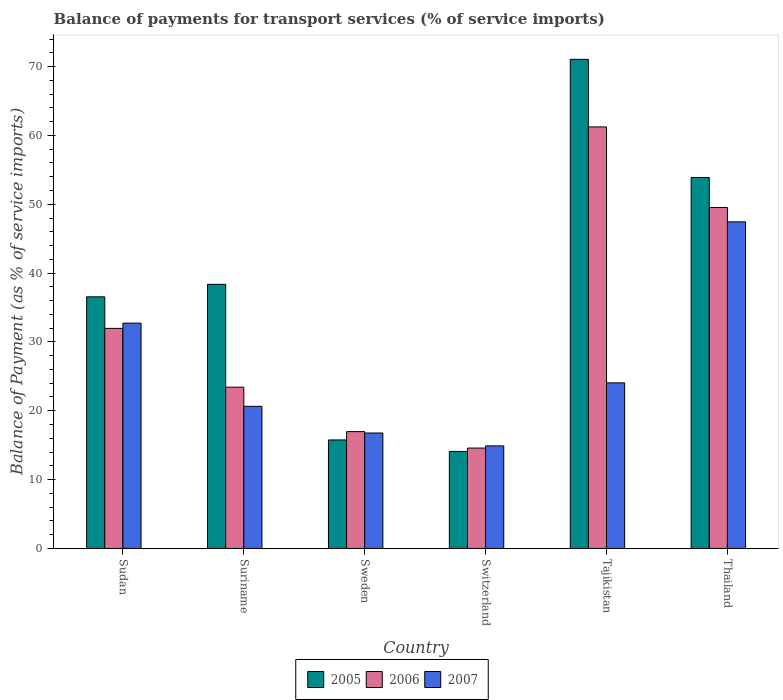What is the label of the 5th group of bars from the left?
Offer a terse response. Tajikistan. In how many cases, is the number of bars for a given country not equal to the number of legend labels?
Your response must be concise. 0. What is the balance of payments for transport services in 2006 in Switzerland?
Offer a very short reply. 14.58. Across all countries, what is the maximum balance of payments for transport services in 2006?
Offer a terse response. 61.23. Across all countries, what is the minimum balance of payments for transport services in 2006?
Keep it short and to the point. 14.58. In which country was the balance of payments for transport services in 2007 maximum?
Keep it short and to the point. Thailand. In which country was the balance of payments for transport services in 2005 minimum?
Provide a short and direct response. Switzerland. What is the total balance of payments for transport services in 2005 in the graph?
Offer a terse response. 229.7. What is the difference between the balance of payments for transport services in 2005 in Sudan and that in Tajikistan?
Offer a terse response. -34.5. What is the difference between the balance of payments for transport services in 2007 in Thailand and the balance of payments for transport services in 2005 in Suriname?
Ensure brevity in your answer.  9.08. What is the average balance of payments for transport services in 2005 per country?
Give a very brief answer. 38.28. What is the difference between the balance of payments for transport services of/in 2006 and balance of payments for transport services of/in 2005 in Thailand?
Your answer should be compact. -4.36. What is the ratio of the balance of payments for transport services in 2006 in Sudan to that in Suriname?
Your response must be concise. 1.36. Is the balance of payments for transport services in 2007 in Suriname less than that in Switzerland?
Keep it short and to the point. No. Is the difference between the balance of payments for transport services in 2006 in Sudan and Suriname greater than the difference between the balance of payments for transport services in 2005 in Sudan and Suriname?
Keep it short and to the point. Yes. What is the difference between the highest and the second highest balance of payments for transport services in 2007?
Make the answer very short. 8.68. What is the difference between the highest and the lowest balance of payments for transport services in 2007?
Offer a terse response. 32.54. In how many countries, is the balance of payments for transport services in 2007 greater than the average balance of payments for transport services in 2007 taken over all countries?
Make the answer very short. 2. What does the 1st bar from the right in Tajikistan represents?
Offer a very short reply. 2007. Is it the case that in every country, the sum of the balance of payments for transport services in 2005 and balance of payments for transport services in 2007 is greater than the balance of payments for transport services in 2006?
Your answer should be very brief. Yes. Are all the bars in the graph horizontal?
Give a very brief answer. No. How many countries are there in the graph?
Keep it short and to the point. 6. What is the difference between two consecutive major ticks on the Y-axis?
Provide a succinct answer. 10. Are the values on the major ticks of Y-axis written in scientific E-notation?
Make the answer very short. No. Does the graph contain any zero values?
Your answer should be very brief. No. Does the graph contain grids?
Offer a very short reply. No. Where does the legend appear in the graph?
Provide a succinct answer. Bottom center. How many legend labels are there?
Make the answer very short. 3. How are the legend labels stacked?
Provide a succinct answer. Horizontal. What is the title of the graph?
Ensure brevity in your answer.  Balance of payments for transport services (% of service imports). Does "2015" appear as one of the legend labels in the graph?
Give a very brief answer. No. What is the label or title of the X-axis?
Your answer should be very brief. Country. What is the label or title of the Y-axis?
Your answer should be compact. Balance of Payment (as % of service imports). What is the Balance of Payment (as % of service imports) of 2005 in Sudan?
Make the answer very short. 36.55. What is the Balance of Payment (as % of service imports) of 2006 in Sudan?
Make the answer very short. 31.96. What is the Balance of Payment (as % of service imports) in 2007 in Sudan?
Give a very brief answer. 32.73. What is the Balance of Payment (as % of service imports) of 2005 in Suriname?
Provide a short and direct response. 38.37. What is the Balance of Payment (as % of service imports) in 2006 in Suriname?
Offer a terse response. 23.42. What is the Balance of Payment (as % of service imports) in 2007 in Suriname?
Give a very brief answer. 20.64. What is the Balance of Payment (as % of service imports) of 2005 in Sweden?
Your answer should be compact. 15.76. What is the Balance of Payment (as % of service imports) of 2006 in Sweden?
Give a very brief answer. 16.97. What is the Balance of Payment (as % of service imports) in 2007 in Sweden?
Keep it short and to the point. 16.77. What is the Balance of Payment (as % of service imports) in 2005 in Switzerland?
Keep it short and to the point. 14.09. What is the Balance of Payment (as % of service imports) in 2006 in Switzerland?
Your response must be concise. 14.58. What is the Balance of Payment (as % of service imports) in 2007 in Switzerland?
Provide a short and direct response. 14.9. What is the Balance of Payment (as % of service imports) of 2005 in Tajikistan?
Keep it short and to the point. 71.05. What is the Balance of Payment (as % of service imports) of 2006 in Tajikistan?
Make the answer very short. 61.23. What is the Balance of Payment (as % of service imports) in 2007 in Tajikistan?
Offer a very short reply. 24.05. What is the Balance of Payment (as % of service imports) of 2005 in Thailand?
Make the answer very short. 53.88. What is the Balance of Payment (as % of service imports) in 2006 in Thailand?
Make the answer very short. 49.53. What is the Balance of Payment (as % of service imports) in 2007 in Thailand?
Provide a short and direct response. 47.44. Across all countries, what is the maximum Balance of Payment (as % of service imports) of 2005?
Ensure brevity in your answer.  71.05. Across all countries, what is the maximum Balance of Payment (as % of service imports) in 2006?
Give a very brief answer. 61.23. Across all countries, what is the maximum Balance of Payment (as % of service imports) of 2007?
Provide a short and direct response. 47.44. Across all countries, what is the minimum Balance of Payment (as % of service imports) in 2005?
Offer a very short reply. 14.09. Across all countries, what is the minimum Balance of Payment (as % of service imports) of 2006?
Keep it short and to the point. 14.58. Across all countries, what is the minimum Balance of Payment (as % of service imports) in 2007?
Keep it short and to the point. 14.9. What is the total Balance of Payment (as % of service imports) of 2005 in the graph?
Provide a short and direct response. 229.7. What is the total Balance of Payment (as % of service imports) in 2006 in the graph?
Make the answer very short. 197.7. What is the total Balance of Payment (as % of service imports) of 2007 in the graph?
Make the answer very short. 156.53. What is the difference between the Balance of Payment (as % of service imports) of 2005 in Sudan and that in Suriname?
Give a very brief answer. -1.82. What is the difference between the Balance of Payment (as % of service imports) in 2006 in Sudan and that in Suriname?
Offer a terse response. 8.54. What is the difference between the Balance of Payment (as % of service imports) of 2007 in Sudan and that in Suriname?
Make the answer very short. 12.08. What is the difference between the Balance of Payment (as % of service imports) of 2005 in Sudan and that in Sweden?
Make the answer very short. 20.79. What is the difference between the Balance of Payment (as % of service imports) in 2006 in Sudan and that in Sweden?
Make the answer very short. 14.99. What is the difference between the Balance of Payment (as % of service imports) of 2007 in Sudan and that in Sweden?
Offer a terse response. 15.96. What is the difference between the Balance of Payment (as % of service imports) in 2005 in Sudan and that in Switzerland?
Offer a terse response. 22.46. What is the difference between the Balance of Payment (as % of service imports) in 2006 in Sudan and that in Switzerland?
Your answer should be compact. 17.38. What is the difference between the Balance of Payment (as % of service imports) of 2007 in Sudan and that in Switzerland?
Your answer should be very brief. 17.83. What is the difference between the Balance of Payment (as % of service imports) in 2005 in Sudan and that in Tajikistan?
Provide a short and direct response. -34.5. What is the difference between the Balance of Payment (as % of service imports) in 2006 in Sudan and that in Tajikistan?
Make the answer very short. -29.27. What is the difference between the Balance of Payment (as % of service imports) of 2007 in Sudan and that in Tajikistan?
Offer a terse response. 8.68. What is the difference between the Balance of Payment (as % of service imports) in 2005 in Sudan and that in Thailand?
Give a very brief answer. -17.33. What is the difference between the Balance of Payment (as % of service imports) in 2006 in Sudan and that in Thailand?
Give a very brief answer. -17.56. What is the difference between the Balance of Payment (as % of service imports) of 2007 in Sudan and that in Thailand?
Your answer should be compact. -14.71. What is the difference between the Balance of Payment (as % of service imports) of 2005 in Suriname and that in Sweden?
Give a very brief answer. 22.6. What is the difference between the Balance of Payment (as % of service imports) in 2006 in Suriname and that in Sweden?
Provide a short and direct response. 6.45. What is the difference between the Balance of Payment (as % of service imports) of 2007 in Suriname and that in Sweden?
Give a very brief answer. 3.88. What is the difference between the Balance of Payment (as % of service imports) of 2005 in Suriname and that in Switzerland?
Provide a short and direct response. 24.28. What is the difference between the Balance of Payment (as % of service imports) of 2006 in Suriname and that in Switzerland?
Give a very brief answer. 8.84. What is the difference between the Balance of Payment (as % of service imports) of 2007 in Suriname and that in Switzerland?
Your answer should be compact. 5.75. What is the difference between the Balance of Payment (as % of service imports) of 2005 in Suriname and that in Tajikistan?
Give a very brief answer. -32.68. What is the difference between the Balance of Payment (as % of service imports) in 2006 in Suriname and that in Tajikistan?
Your response must be concise. -37.81. What is the difference between the Balance of Payment (as % of service imports) of 2007 in Suriname and that in Tajikistan?
Provide a succinct answer. -3.41. What is the difference between the Balance of Payment (as % of service imports) in 2005 in Suriname and that in Thailand?
Give a very brief answer. -15.52. What is the difference between the Balance of Payment (as % of service imports) of 2006 in Suriname and that in Thailand?
Your answer should be very brief. -26.1. What is the difference between the Balance of Payment (as % of service imports) of 2007 in Suriname and that in Thailand?
Your answer should be compact. -26.8. What is the difference between the Balance of Payment (as % of service imports) in 2005 in Sweden and that in Switzerland?
Provide a succinct answer. 1.67. What is the difference between the Balance of Payment (as % of service imports) in 2006 in Sweden and that in Switzerland?
Offer a terse response. 2.39. What is the difference between the Balance of Payment (as % of service imports) of 2007 in Sweden and that in Switzerland?
Provide a succinct answer. 1.87. What is the difference between the Balance of Payment (as % of service imports) of 2005 in Sweden and that in Tajikistan?
Your answer should be compact. -55.29. What is the difference between the Balance of Payment (as % of service imports) of 2006 in Sweden and that in Tajikistan?
Offer a very short reply. -44.26. What is the difference between the Balance of Payment (as % of service imports) in 2007 in Sweden and that in Tajikistan?
Your response must be concise. -7.29. What is the difference between the Balance of Payment (as % of service imports) of 2005 in Sweden and that in Thailand?
Make the answer very short. -38.12. What is the difference between the Balance of Payment (as % of service imports) in 2006 in Sweden and that in Thailand?
Provide a short and direct response. -32.56. What is the difference between the Balance of Payment (as % of service imports) in 2007 in Sweden and that in Thailand?
Provide a succinct answer. -30.67. What is the difference between the Balance of Payment (as % of service imports) in 2005 in Switzerland and that in Tajikistan?
Keep it short and to the point. -56.96. What is the difference between the Balance of Payment (as % of service imports) of 2006 in Switzerland and that in Tajikistan?
Make the answer very short. -46.65. What is the difference between the Balance of Payment (as % of service imports) in 2007 in Switzerland and that in Tajikistan?
Your response must be concise. -9.16. What is the difference between the Balance of Payment (as % of service imports) of 2005 in Switzerland and that in Thailand?
Make the answer very short. -39.79. What is the difference between the Balance of Payment (as % of service imports) in 2006 in Switzerland and that in Thailand?
Provide a succinct answer. -34.95. What is the difference between the Balance of Payment (as % of service imports) of 2007 in Switzerland and that in Thailand?
Offer a very short reply. -32.54. What is the difference between the Balance of Payment (as % of service imports) of 2005 in Tajikistan and that in Thailand?
Keep it short and to the point. 17.16. What is the difference between the Balance of Payment (as % of service imports) of 2006 in Tajikistan and that in Thailand?
Offer a very short reply. 11.7. What is the difference between the Balance of Payment (as % of service imports) of 2007 in Tajikistan and that in Thailand?
Offer a terse response. -23.39. What is the difference between the Balance of Payment (as % of service imports) in 2005 in Sudan and the Balance of Payment (as % of service imports) in 2006 in Suriname?
Offer a terse response. 13.13. What is the difference between the Balance of Payment (as % of service imports) of 2005 in Sudan and the Balance of Payment (as % of service imports) of 2007 in Suriname?
Your answer should be very brief. 15.91. What is the difference between the Balance of Payment (as % of service imports) of 2006 in Sudan and the Balance of Payment (as % of service imports) of 2007 in Suriname?
Your answer should be compact. 11.32. What is the difference between the Balance of Payment (as % of service imports) of 2005 in Sudan and the Balance of Payment (as % of service imports) of 2006 in Sweden?
Offer a very short reply. 19.58. What is the difference between the Balance of Payment (as % of service imports) of 2005 in Sudan and the Balance of Payment (as % of service imports) of 2007 in Sweden?
Give a very brief answer. 19.78. What is the difference between the Balance of Payment (as % of service imports) in 2006 in Sudan and the Balance of Payment (as % of service imports) in 2007 in Sweden?
Provide a succinct answer. 15.2. What is the difference between the Balance of Payment (as % of service imports) in 2005 in Sudan and the Balance of Payment (as % of service imports) in 2006 in Switzerland?
Offer a very short reply. 21.97. What is the difference between the Balance of Payment (as % of service imports) in 2005 in Sudan and the Balance of Payment (as % of service imports) in 2007 in Switzerland?
Provide a succinct answer. 21.65. What is the difference between the Balance of Payment (as % of service imports) of 2006 in Sudan and the Balance of Payment (as % of service imports) of 2007 in Switzerland?
Make the answer very short. 17.07. What is the difference between the Balance of Payment (as % of service imports) of 2005 in Sudan and the Balance of Payment (as % of service imports) of 2006 in Tajikistan?
Your answer should be compact. -24.68. What is the difference between the Balance of Payment (as % of service imports) of 2005 in Sudan and the Balance of Payment (as % of service imports) of 2007 in Tajikistan?
Your answer should be compact. 12.5. What is the difference between the Balance of Payment (as % of service imports) of 2006 in Sudan and the Balance of Payment (as % of service imports) of 2007 in Tajikistan?
Keep it short and to the point. 7.91. What is the difference between the Balance of Payment (as % of service imports) of 2005 in Sudan and the Balance of Payment (as % of service imports) of 2006 in Thailand?
Your response must be concise. -12.98. What is the difference between the Balance of Payment (as % of service imports) of 2005 in Sudan and the Balance of Payment (as % of service imports) of 2007 in Thailand?
Your answer should be compact. -10.89. What is the difference between the Balance of Payment (as % of service imports) of 2006 in Sudan and the Balance of Payment (as % of service imports) of 2007 in Thailand?
Provide a short and direct response. -15.48. What is the difference between the Balance of Payment (as % of service imports) of 2005 in Suriname and the Balance of Payment (as % of service imports) of 2006 in Sweden?
Give a very brief answer. 21.4. What is the difference between the Balance of Payment (as % of service imports) of 2005 in Suriname and the Balance of Payment (as % of service imports) of 2007 in Sweden?
Give a very brief answer. 21.6. What is the difference between the Balance of Payment (as % of service imports) in 2006 in Suriname and the Balance of Payment (as % of service imports) in 2007 in Sweden?
Ensure brevity in your answer.  6.66. What is the difference between the Balance of Payment (as % of service imports) of 2005 in Suriname and the Balance of Payment (as % of service imports) of 2006 in Switzerland?
Keep it short and to the point. 23.78. What is the difference between the Balance of Payment (as % of service imports) in 2005 in Suriname and the Balance of Payment (as % of service imports) in 2007 in Switzerland?
Ensure brevity in your answer.  23.47. What is the difference between the Balance of Payment (as % of service imports) in 2006 in Suriname and the Balance of Payment (as % of service imports) in 2007 in Switzerland?
Keep it short and to the point. 8.53. What is the difference between the Balance of Payment (as % of service imports) in 2005 in Suriname and the Balance of Payment (as % of service imports) in 2006 in Tajikistan?
Ensure brevity in your answer.  -22.87. What is the difference between the Balance of Payment (as % of service imports) in 2005 in Suriname and the Balance of Payment (as % of service imports) in 2007 in Tajikistan?
Make the answer very short. 14.31. What is the difference between the Balance of Payment (as % of service imports) of 2006 in Suriname and the Balance of Payment (as % of service imports) of 2007 in Tajikistan?
Make the answer very short. -0.63. What is the difference between the Balance of Payment (as % of service imports) of 2005 in Suriname and the Balance of Payment (as % of service imports) of 2006 in Thailand?
Provide a succinct answer. -11.16. What is the difference between the Balance of Payment (as % of service imports) of 2005 in Suriname and the Balance of Payment (as % of service imports) of 2007 in Thailand?
Offer a very short reply. -9.08. What is the difference between the Balance of Payment (as % of service imports) of 2006 in Suriname and the Balance of Payment (as % of service imports) of 2007 in Thailand?
Provide a short and direct response. -24.02. What is the difference between the Balance of Payment (as % of service imports) in 2005 in Sweden and the Balance of Payment (as % of service imports) in 2006 in Switzerland?
Make the answer very short. 1.18. What is the difference between the Balance of Payment (as % of service imports) in 2005 in Sweden and the Balance of Payment (as % of service imports) in 2007 in Switzerland?
Offer a terse response. 0.87. What is the difference between the Balance of Payment (as % of service imports) of 2006 in Sweden and the Balance of Payment (as % of service imports) of 2007 in Switzerland?
Offer a very short reply. 2.07. What is the difference between the Balance of Payment (as % of service imports) in 2005 in Sweden and the Balance of Payment (as % of service imports) in 2006 in Tajikistan?
Keep it short and to the point. -45.47. What is the difference between the Balance of Payment (as % of service imports) of 2005 in Sweden and the Balance of Payment (as % of service imports) of 2007 in Tajikistan?
Your answer should be very brief. -8.29. What is the difference between the Balance of Payment (as % of service imports) of 2006 in Sweden and the Balance of Payment (as % of service imports) of 2007 in Tajikistan?
Your answer should be very brief. -7.08. What is the difference between the Balance of Payment (as % of service imports) of 2005 in Sweden and the Balance of Payment (as % of service imports) of 2006 in Thailand?
Offer a terse response. -33.77. What is the difference between the Balance of Payment (as % of service imports) in 2005 in Sweden and the Balance of Payment (as % of service imports) in 2007 in Thailand?
Provide a succinct answer. -31.68. What is the difference between the Balance of Payment (as % of service imports) of 2006 in Sweden and the Balance of Payment (as % of service imports) of 2007 in Thailand?
Your answer should be compact. -30.47. What is the difference between the Balance of Payment (as % of service imports) in 2005 in Switzerland and the Balance of Payment (as % of service imports) in 2006 in Tajikistan?
Provide a short and direct response. -47.14. What is the difference between the Balance of Payment (as % of service imports) in 2005 in Switzerland and the Balance of Payment (as % of service imports) in 2007 in Tajikistan?
Offer a terse response. -9.96. What is the difference between the Balance of Payment (as % of service imports) in 2006 in Switzerland and the Balance of Payment (as % of service imports) in 2007 in Tajikistan?
Your answer should be very brief. -9.47. What is the difference between the Balance of Payment (as % of service imports) of 2005 in Switzerland and the Balance of Payment (as % of service imports) of 2006 in Thailand?
Provide a succinct answer. -35.44. What is the difference between the Balance of Payment (as % of service imports) of 2005 in Switzerland and the Balance of Payment (as % of service imports) of 2007 in Thailand?
Keep it short and to the point. -33.35. What is the difference between the Balance of Payment (as % of service imports) of 2006 in Switzerland and the Balance of Payment (as % of service imports) of 2007 in Thailand?
Offer a terse response. -32.86. What is the difference between the Balance of Payment (as % of service imports) in 2005 in Tajikistan and the Balance of Payment (as % of service imports) in 2006 in Thailand?
Your answer should be compact. 21.52. What is the difference between the Balance of Payment (as % of service imports) in 2005 in Tajikistan and the Balance of Payment (as % of service imports) in 2007 in Thailand?
Give a very brief answer. 23.61. What is the difference between the Balance of Payment (as % of service imports) of 2006 in Tajikistan and the Balance of Payment (as % of service imports) of 2007 in Thailand?
Your answer should be compact. 13.79. What is the average Balance of Payment (as % of service imports) of 2005 per country?
Give a very brief answer. 38.28. What is the average Balance of Payment (as % of service imports) in 2006 per country?
Make the answer very short. 32.95. What is the average Balance of Payment (as % of service imports) in 2007 per country?
Provide a succinct answer. 26.09. What is the difference between the Balance of Payment (as % of service imports) of 2005 and Balance of Payment (as % of service imports) of 2006 in Sudan?
Ensure brevity in your answer.  4.59. What is the difference between the Balance of Payment (as % of service imports) of 2005 and Balance of Payment (as % of service imports) of 2007 in Sudan?
Your answer should be compact. 3.82. What is the difference between the Balance of Payment (as % of service imports) of 2006 and Balance of Payment (as % of service imports) of 2007 in Sudan?
Keep it short and to the point. -0.76. What is the difference between the Balance of Payment (as % of service imports) in 2005 and Balance of Payment (as % of service imports) in 2006 in Suriname?
Provide a succinct answer. 14.94. What is the difference between the Balance of Payment (as % of service imports) of 2005 and Balance of Payment (as % of service imports) of 2007 in Suriname?
Your answer should be very brief. 17.72. What is the difference between the Balance of Payment (as % of service imports) in 2006 and Balance of Payment (as % of service imports) in 2007 in Suriname?
Your response must be concise. 2.78. What is the difference between the Balance of Payment (as % of service imports) in 2005 and Balance of Payment (as % of service imports) in 2006 in Sweden?
Offer a terse response. -1.21. What is the difference between the Balance of Payment (as % of service imports) in 2005 and Balance of Payment (as % of service imports) in 2007 in Sweden?
Make the answer very short. -1. What is the difference between the Balance of Payment (as % of service imports) of 2006 and Balance of Payment (as % of service imports) of 2007 in Sweden?
Provide a succinct answer. 0.2. What is the difference between the Balance of Payment (as % of service imports) in 2005 and Balance of Payment (as % of service imports) in 2006 in Switzerland?
Offer a very short reply. -0.49. What is the difference between the Balance of Payment (as % of service imports) in 2005 and Balance of Payment (as % of service imports) in 2007 in Switzerland?
Your answer should be very brief. -0.81. What is the difference between the Balance of Payment (as % of service imports) of 2006 and Balance of Payment (as % of service imports) of 2007 in Switzerland?
Offer a terse response. -0.32. What is the difference between the Balance of Payment (as % of service imports) of 2005 and Balance of Payment (as % of service imports) of 2006 in Tajikistan?
Your response must be concise. 9.82. What is the difference between the Balance of Payment (as % of service imports) of 2005 and Balance of Payment (as % of service imports) of 2007 in Tajikistan?
Your answer should be compact. 47. What is the difference between the Balance of Payment (as % of service imports) of 2006 and Balance of Payment (as % of service imports) of 2007 in Tajikistan?
Give a very brief answer. 37.18. What is the difference between the Balance of Payment (as % of service imports) of 2005 and Balance of Payment (as % of service imports) of 2006 in Thailand?
Offer a very short reply. 4.36. What is the difference between the Balance of Payment (as % of service imports) in 2005 and Balance of Payment (as % of service imports) in 2007 in Thailand?
Offer a very short reply. 6.44. What is the difference between the Balance of Payment (as % of service imports) of 2006 and Balance of Payment (as % of service imports) of 2007 in Thailand?
Your response must be concise. 2.09. What is the ratio of the Balance of Payment (as % of service imports) of 2005 in Sudan to that in Suriname?
Offer a terse response. 0.95. What is the ratio of the Balance of Payment (as % of service imports) of 2006 in Sudan to that in Suriname?
Provide a short and direct response. 1.36. What is the ratio of the Balance of Payment (as % of service imports) in 2007 in Sudan to that in Suriname?
Offer a terse response. 1.59. What is the ratio of the Balance of Payment (as % of service imports) in 2005 in Sudan to that in Sweden?
Ensure brevity in your answer.  2.32. What is the ratio of the Balance of Payment (as % of service imports) of 2006 in Sudan to that in Sweden?
Provide a short and direct response. 1.88. What is the ratio of the Balance of Payment (as % of service imports) of 2007 in Sudan to that in Sweden?
Your response must be concise. 1.95. What is the ratio of the Balance of Payment (as % of service imports) of 2005 in Sudan to that in Switzerland?
Offer a very short reply. 2.59. What is the ratio of the Balance of Payment (as % of service imports) of 2006 in Sudan to that in Switzerland?
Ensure brevity in your answer.  2.19. What is the ratio of the Balance of Payment (as % of service imports) in 2007 in Sudan to that in Switzerland?
Your response must be concise. 2.2. What is the ratio of the Balance of Payment (as % of service imports) of 2005 in Sudan to that in Tajikistan?
Offer a very short reply. 0.51. What is the ratio of the Balance of Payment (as % of service imports) of 2006 in Sudan to that in Tajikistan?
Keep it short and to the point. 0.52. What is the ratio of the Balance of Payment (as % of service imports) of 2007 in Sudan to that in Tajikistan?
Offer a terse response. 1.36. What is the ratio of the Balance of Payment (as % of service imports) in 2005 in Sudan to that in Thailand?
Your answer should be very brief. 0.68. What is the ratio of the Balance of Payment (as % of service imports) in 2006 in Sudan to that in Thailand?
Your answer should be compact. 0.65. What is the ratio of the Balance of Payment (as % of service imports) of 2007 in Sudan to that in Thailand?
Provide a succinct answer. 0.69. What is the ratio of the Balance of Payment (as % of service imports) in 2005 in Suriname to that in Sweden?
Give a very brief answer. 2.43. What is the ratio of the Balance of Payment (as % of service imports) of 2006 in Suriname to that in Sweden?
Your response must be concise. 1.38. What is the ratio of the Balance of Payment (as % of service imports) in 2007 in Suriname to that in Sweden?
Your answer should be very brief. 1.23. What is the ratio of the Balance of Payment (as % of service imports) in 2005 in Suriname to that in Switzerland?
Offer a terse response. 2.72. What is the ratio of the Balance of Payment (as % of service imports) of 2006 in Suriname to that in Switzerland?
Provide a succinct answer. 1.61. What is the ratio of the Balance of Payment (as % of service imports) of 2007 in Suriname to that in Switzerland?
Provide a succinct answer. 1.39. What is the ratio of the Balance of Payment (as % of service imports) in 2005 in Suriname to that in Tajikistan?
Give a very brief answer. 0.54. What is the ratio of the Balance of Payment (as % of service imports) in 2006 in Suriname to that in Tajikistan?
Make the answer very short. 0.38. What is the ratio of the Balance of Payment (as % of service imports) of 2007 in Suriname to that in Tajikistan?
Offer a very short reply. 0.86. What is the ratio of the Balance of Payment (as % of service imports) of 2005 in Suriname to that in Thailand?
Keep it short and to the point. 0.71. What is the ratio of the Balance of Payment (as % of service imports) in 2006 in Suriname to that in Thailand?
Offer a very short reply. 0.47. What is the ratio of the Balance of Payment (as % of service imports) in 2007 in Suriname to that in Thailand?
Your response must be concise. 0.44. What is the ratio of the Balance of Payment (as % of service imports) in 2005 in Sweden to that in Switzerland?
Provide a short and direct response. 1.12. What is the ratio of the Balance of Payment (as % of service imports) of 2006 in Sweden to that in Switzerland?
Offer a very short reply. 1.16. What is the ratio of the Balance of Payment (as % of service imports) in 2007 in Sweden to that in Switzerland?
Your response must be concise. 1.13. What is the ratio of the Balance of Payment (as % of service imports) in 2005 in Sweden to that in Tajikistan?
Give a very brief answer. 0.22. What is the ratio of the Balance of Payment (as % of service imports) of 2006 in Sweden to that in Tajikistan?
Offer a very short reply. 0.28. What is the ratio of the Balance of Payment (as % of service imports) of 2007 in Sweden to that in Tajikistan?
Your answer should be very brief. 0.7. What is the ratio of the Balance of Payment (as % of service imports) of 2005 in Sweden to that in Thailand?
Make the answer very short. 0.29. What is the ratio of the Balance of Payment (as % of service imports) in 2006 in Sweden to that in Thailand?
Give a very brief answer. 0.34. What is the ratio of the Balance of Payment (as % of service imports) of 2007 in Sweden to that in Thailand?
Keep it short and to the point. 0.35. What is the ratio of the Balance of Payment (as % of service imports) in 2005 in Switzerland to that in Tajikistan?
Give a very brief answer. 0.2. What is the ratio of the Balance of Payment (as % of service imports) of 2006 in Switzerland to that in Tajikistan?
Give a very brief answer. 0.24. What is the ratio of the Balance of Payment (as % of service imports) of 2007 in Switzerland to that in Tajikistan?
Your answer should be compact. 0.62. What is the ratio of the Balance of Payment (as % of service imports) of 2005 in Switzerland to that in Thailand?
Your answer should be compact. 0.26. What is the ratio of the Balance of Payment (as % of service imports) of 2006 in Switzerland to that in Thailand?
Your answer should be very brief. 0.29. What is the ratio of the Balance of Payment (as % of service imports) of 2007 in Switzerland to that in Thailand?
Provide a succinct answer. 0.31. What is the ratio of the Balance of Payment (as % of service imports) in 2005 in Tajikistan to that in Thailand?
Ensure brevity in your answer.  1.32. What is the ratio of the Balance of Payment (as % of service imports) in 2006 in Tajikistan to that in Thailand?
Your answer should be very brief. 1.24. What is the ratio of the Balance of Payment (as % of service imports) of 2007 in Tajikistan to that in Thailand?
Your answer should be very brief. 0.51. What is the difference between the highest and the second highest Balance of Payment (as % of service imports) of 2005?
Your answer should be very brief. 17.16. What is the difference between the highest and the second highest Balance of Payment (as % of service imports) in 2006?
Provide a succinct answer. 11.7. What is the difference between the highest and the second highest Balance of Payment (as % of service imports) in 2007?
Provide a short and direct response. 14.71. What is the difference between the highest and the lowest Balance of Payment (as % of service imports) in 2005?
Your response must be concise. 56.96. What is the difference between the highest and the lowest Balance of Payment (as % of service imports) in 2006?
Your response must be concise. 46.65. What is the difference between the highest and the lowest Balance of Payment (as % of service imports) in 2007?
Make the answer very short. 32.54. 